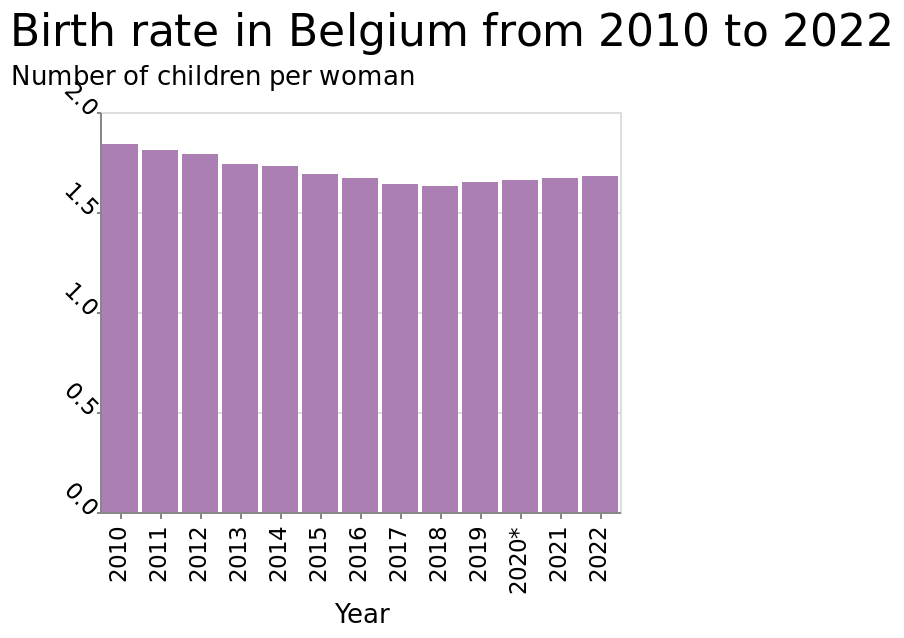<image>
When did Belgium have its highest birth rate?  Belgium had its highest birth rate in 2010. What country or region does the bar diagram represent? Belgium What is being measured on the y-axis of the bar diagram?  Number of children per woman please describe the details of the chart Birth rate in Belgium from 2010 to 2022 is a bar diagram. The x-axis shows Year while the y-axis measures Number of children per woman. How does the birth rate in Belgium in 2018 compare to the peak in 2010? The birth rate in Belgium in 2018 was lower than the peak rate in 2010. 